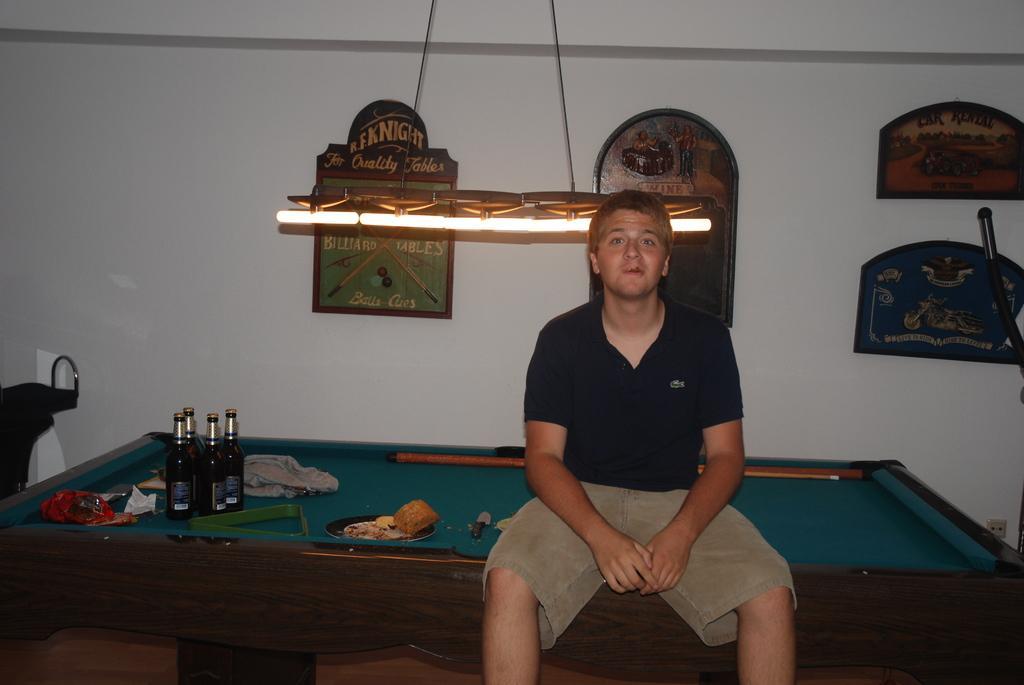Can you describe this image briefly? In this image I can see a man sitting on a snooker table. In the background I can see few frames on this wall. I can also see few bottles on this table. 